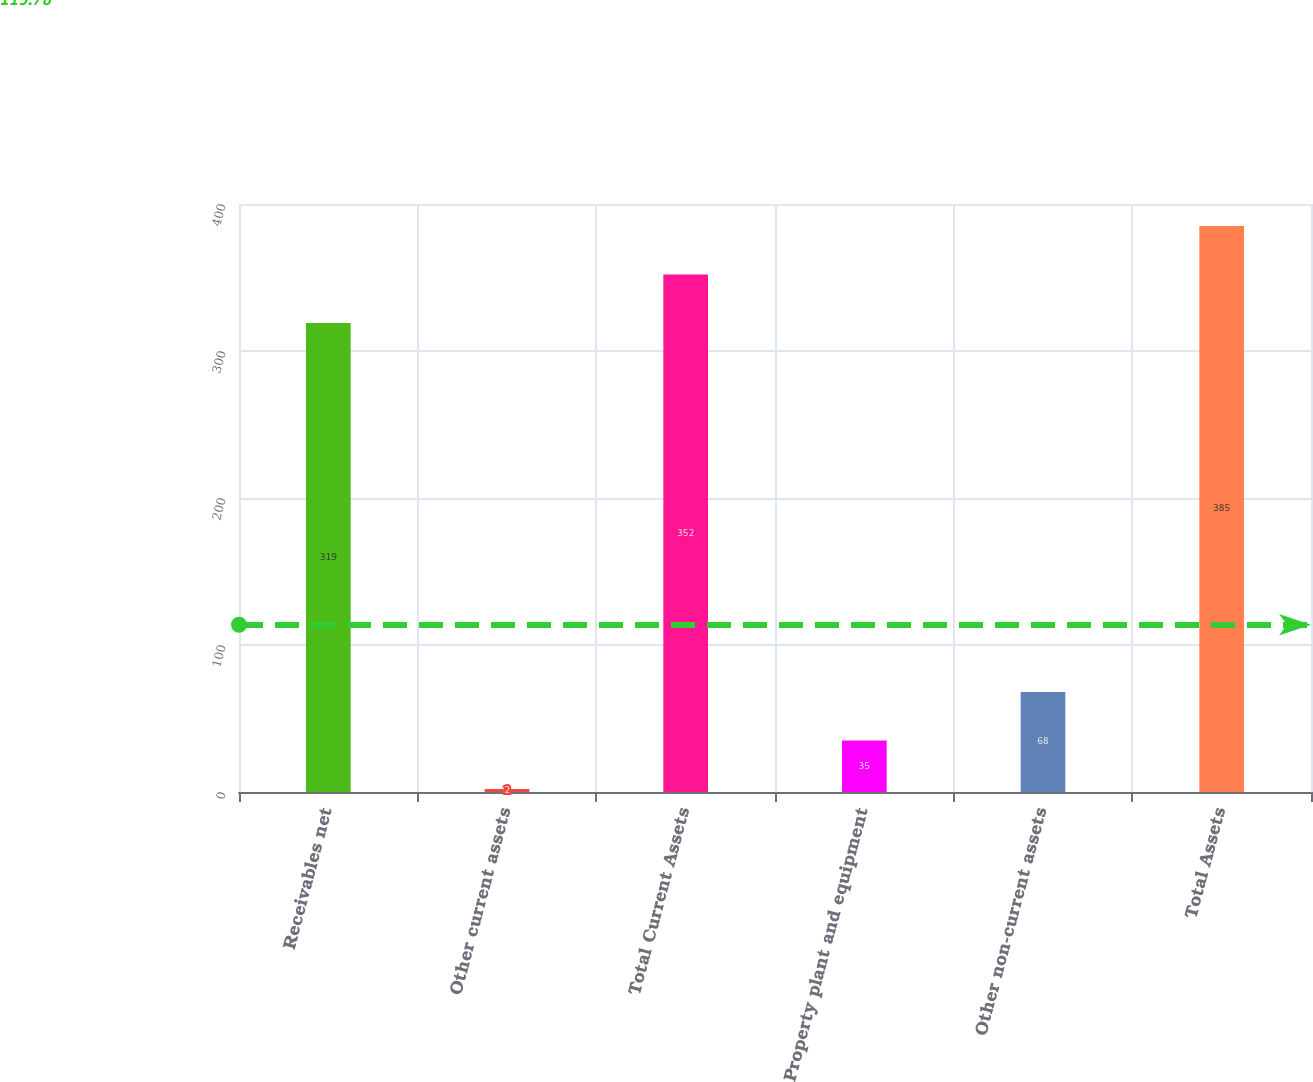<chart> <loc_0><loc_0><loc_500><loc_500><bar_chart><fcel>Receivables net<fcel>Other current assets<fcel>Total Current Assets<fcel>Property plant and equipment<fcel>Other non-current assets<fcel>Total Assets<nl><fcel>319<fcel>2<fcel>352<fcel>35<fcel>68<fcel>385<nl></chart> 